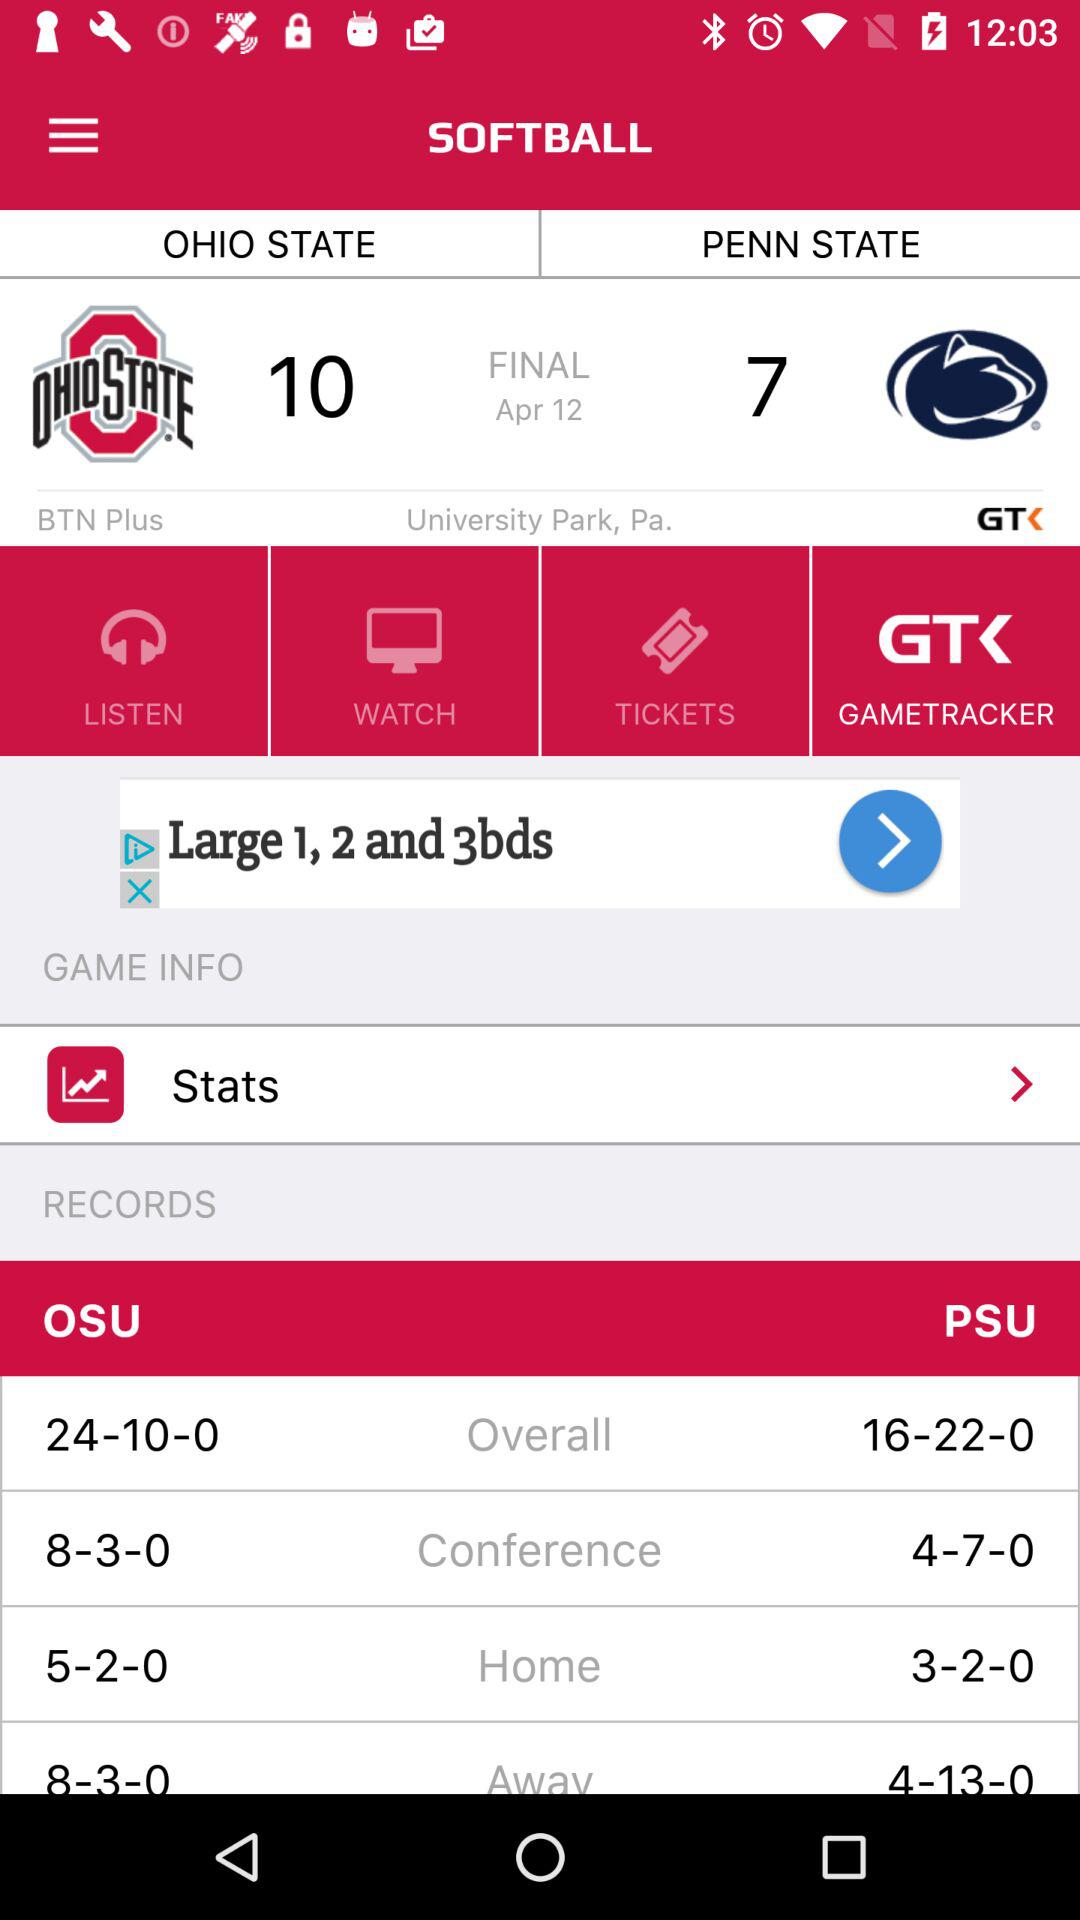What is the location of the match? The location of the match is University Park, Pennsylvania. 